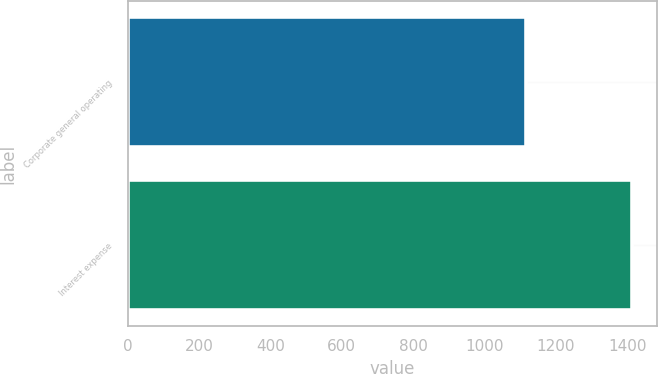Convert chart. <chart><loc_0><loc_0><loc_500><loc_500><bar_chart><fcel>Corporate general operating<fcel>Interest expense<nl><fcel>1115<fcel>1412<nl></chart> 